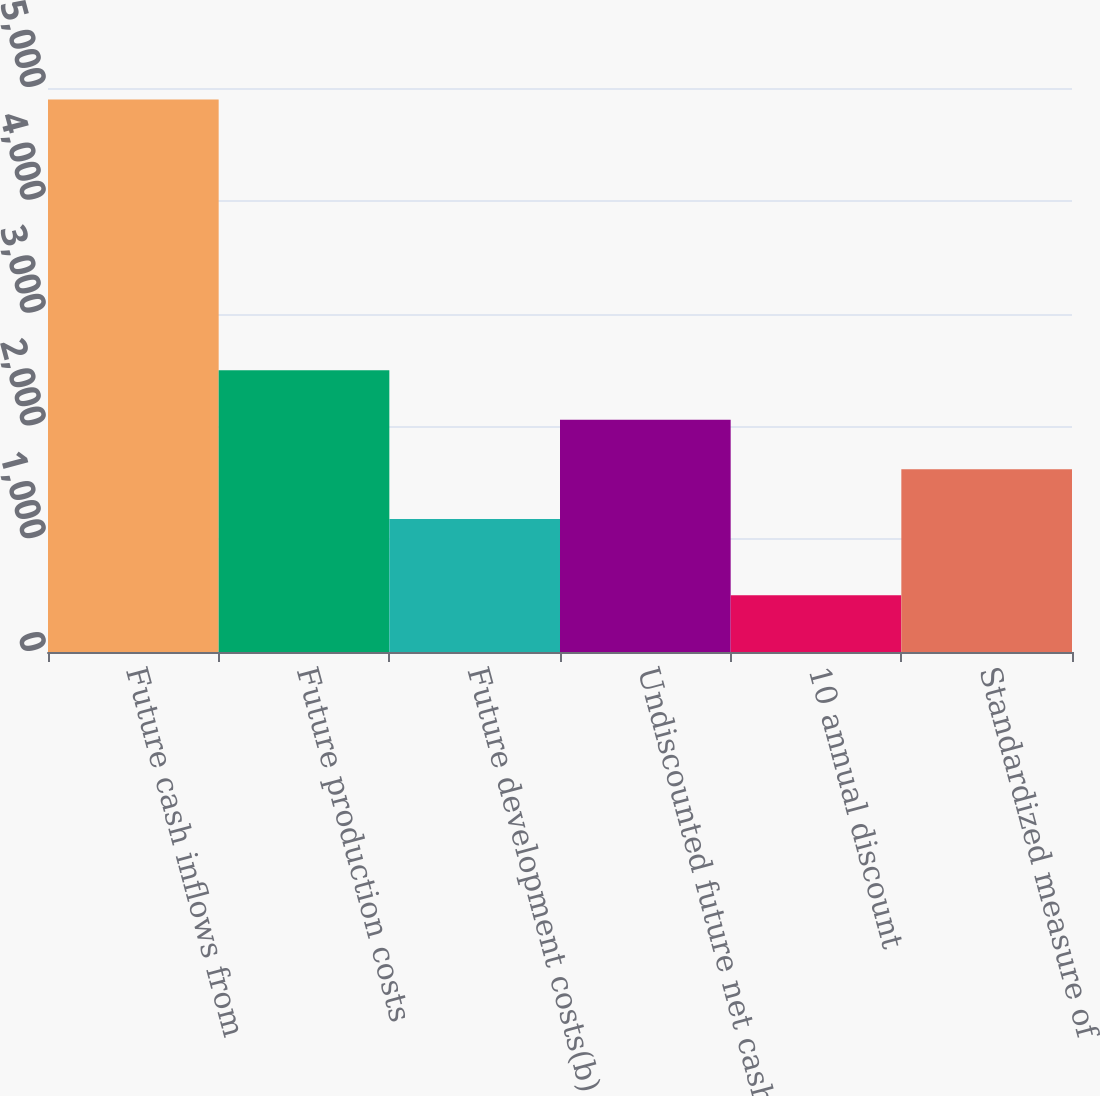Convert chart. <chart><loc_0><loc_0><loc_500><loc_500><bar_chart><fcel>Future cash inflows from<fcel>Future production costs<fcel>Future development costs(b)<fcel>Undiscounted future net cash<fcel>10 annual discount<fcel>Standardized measure of<nl><fcel>4898<fcel>2498.05<fcel>1179.7<fcel>2058.6<fcel>503.5<fcel>1619.15<nl></chart> 